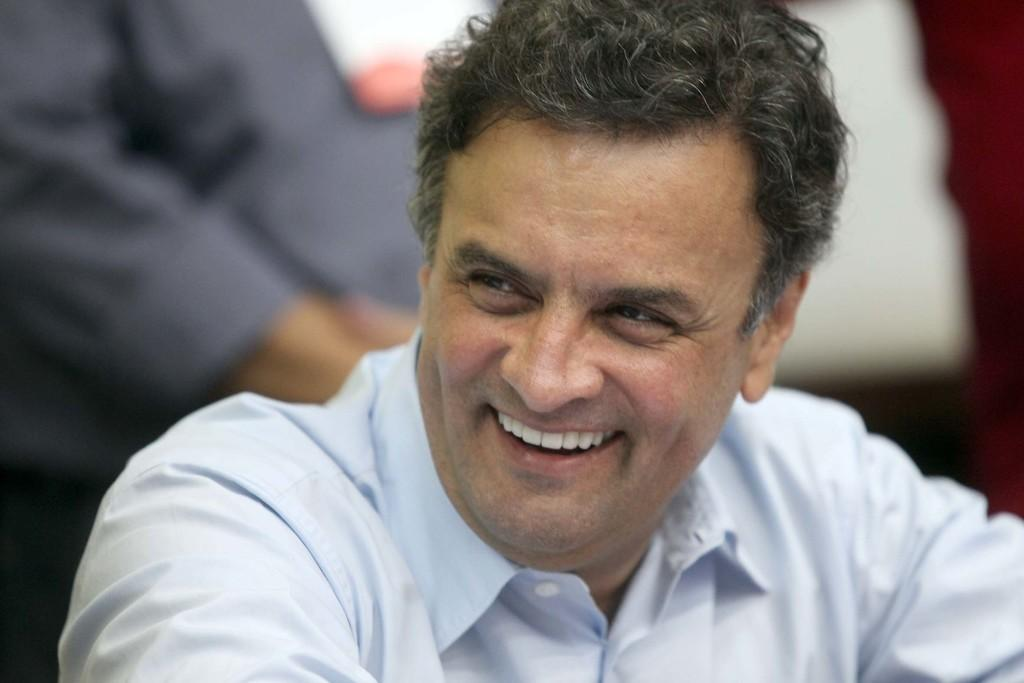What is the main subject of the image? There is a person in the image. What is the person doing in the image? The person is smiling. Can you describe the background of the image? The background of the image is blurred. What type of war is depicted in the image? There is no war depicted in the image; it features a smiling person with a blurred background. What is the person's reaction to the war in the image? There is no war or any indication of a reaction to a war in the image. 